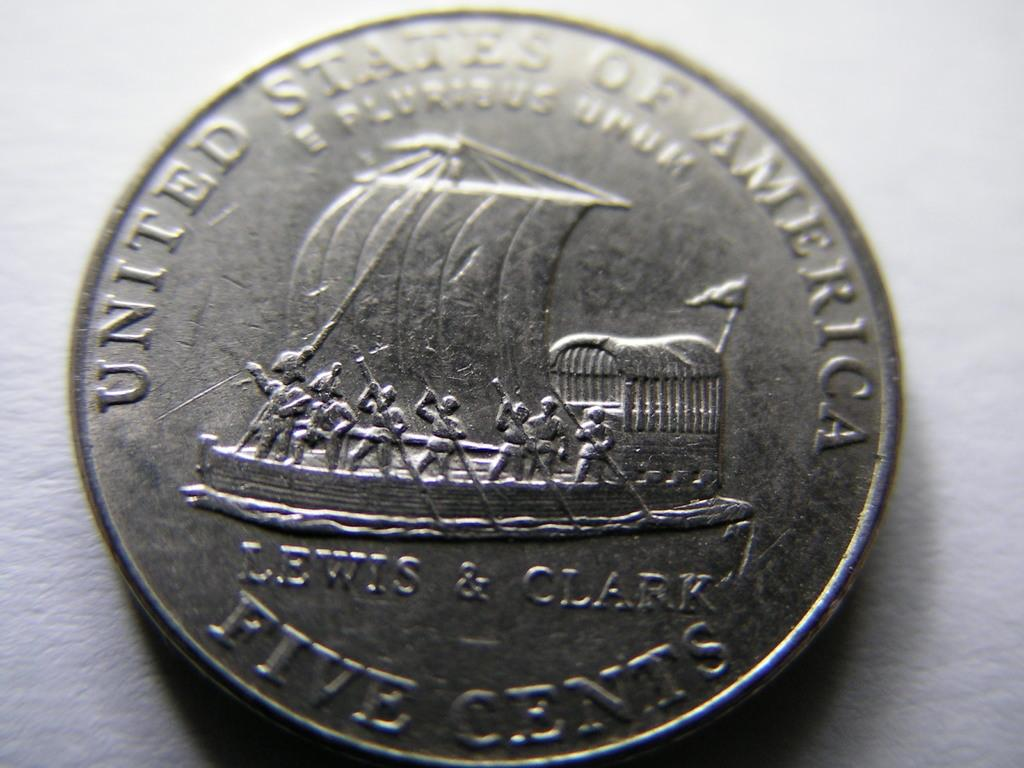<image>
Offer a succinct explanation of the picture presented. A five cent coin from the United States of America is on a white background. 